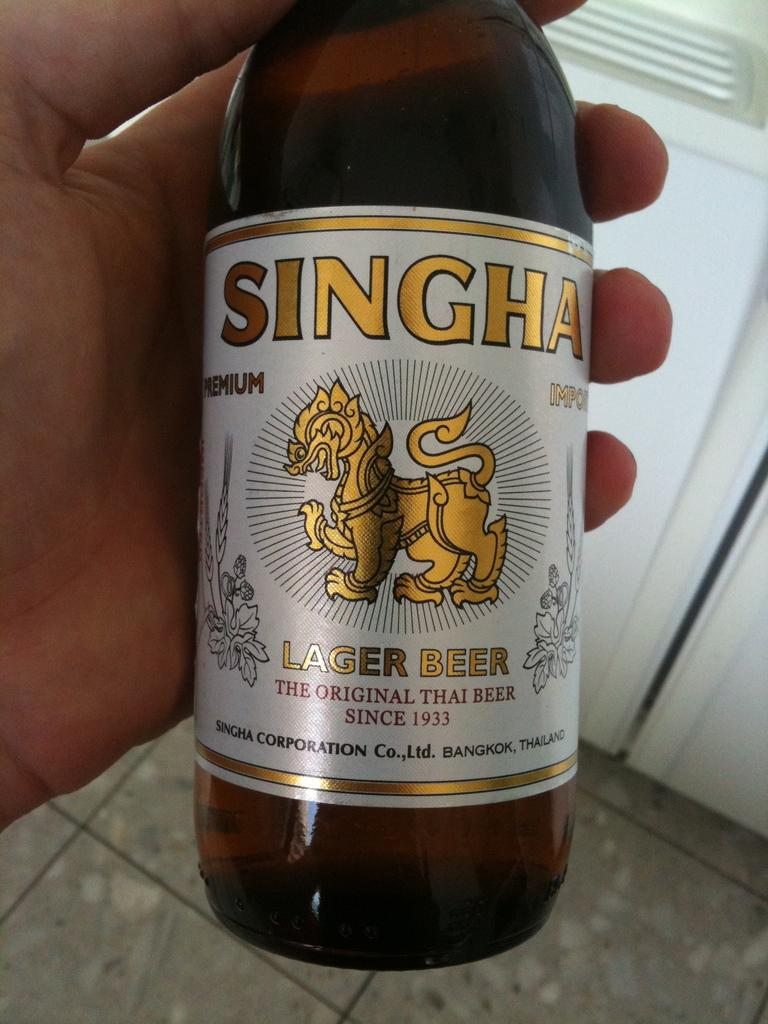Provide a one-sentence caption for the provided image. A hand holds a bottle of Singha lager beer. 